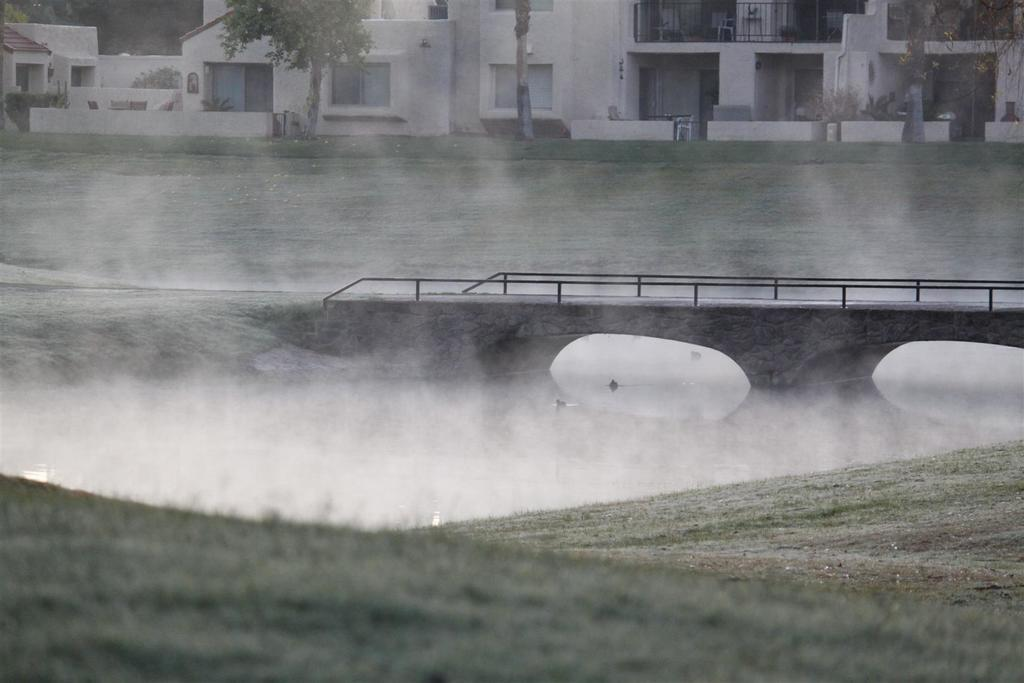What type of structures can be seen in the image? There are buildings in the image. What type of vegetation is present in the image? There are trees and grass in the image. What is visible in front of the building? There is water and a railing in front of the building. What color is the object in front of the building? There is a white color object in front of the building. What is the tendency of the chickens in the image? There are no chickens present in the image, so it is not possible to determine their tendency. What type of flooring is visible in the image? The image does not show any flooring, as it primarily focuses on the buildings, trees, grass, water, railing, and the white object. 